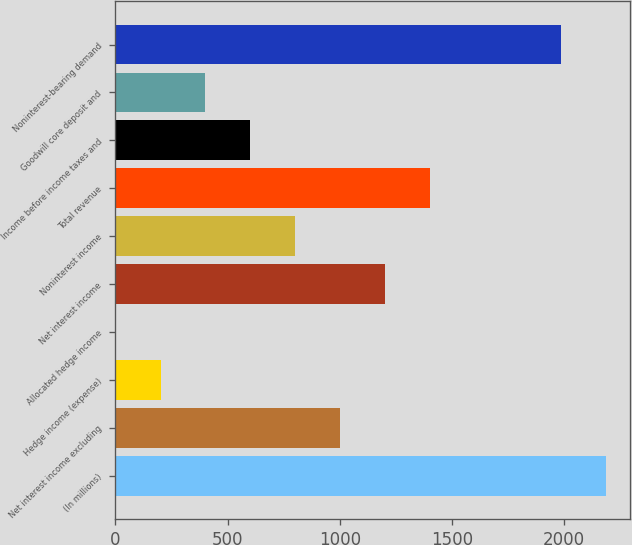Convert chart to OTSL. <chart><loc_0><loc_0><loc_500><loc_500><bar_chart><fcel>(In millions)<fcel>Net interest income excluding<fcel>Hedge income (expense)<fcel>Allocated hedge income<fcel>Net interest income<fcel>Noninterest income<fcel>Total revenue<fcel>Income before income taxes and<fcel>Goodwill core deposit and<fcel>Noninterest-bearing demand<nl><fcel>2186.48<fcel>1002.6<fcel>200.68<fcel>0.2<fcel>1203.08<fcel>802.12<fcel>1403.56<fcel>601.64<fcel>401.16<fcel>1986<nl></chart> 